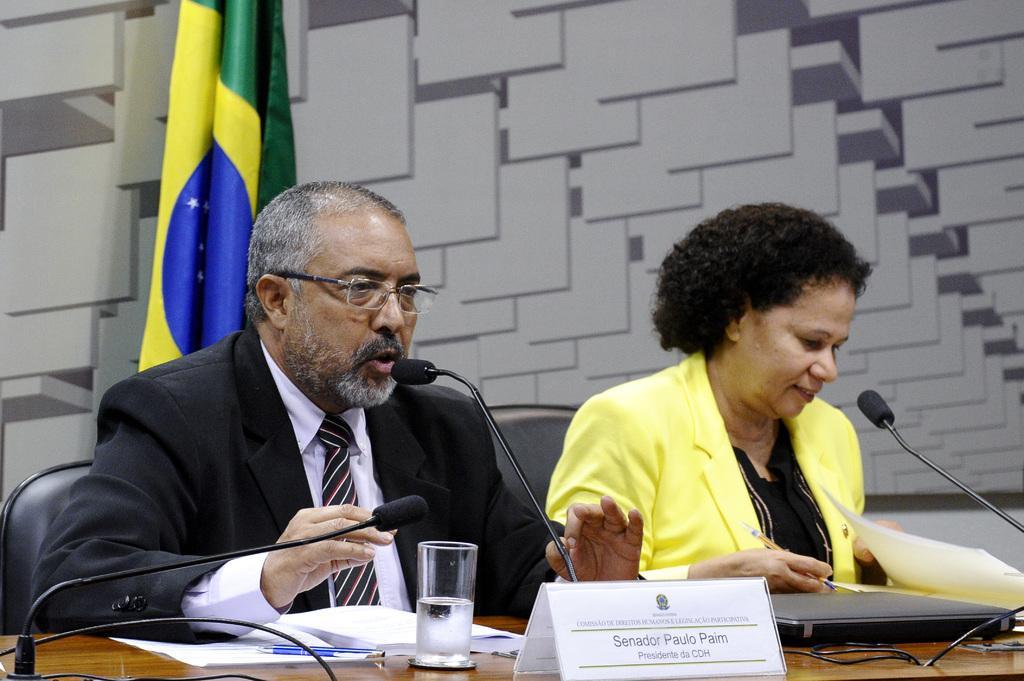Describe this image in one or two sentences. 2 people are sitting on the chairs wearing blazer. In front of them on the table there are microphones, papers, pen, glass and name plate. There is a flag behind them. 